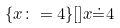<formula> <loc_0><loc_0><loc_500><loc_500>\{ x \colon = 4 \} [ ] x \dot { = } 4</formula> 